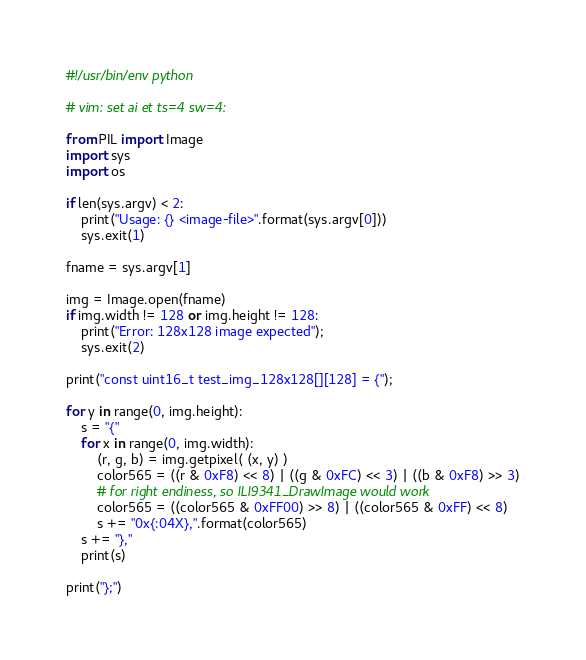Convert code to text. <code><loc_0><loc_0><loc_500><loc_500><_Python_>#!/usr/bin/env python

# vim: set ai et ts=4 sw=4:

from PIL import Image
import sys
import os

if len(sys.argv) < 2:
    print("Usage: {} <image-file>".format(sys.argv[0]))
    sys.exit(1)

fname = sys.argv[1]

img = Image.open(fname)
if img.width != 128 or img.height != 128:
    print("Error: 128x128 image expected");
    sys.exit(2)

print("const uint16_t test_img_128x128[][128] = {");

for y in range(0, img.height):
    s = "{"
    for x in range(0, img.width):
        (r, g, b) = img.getpixel( (x, y) )
        color565 = ((r & 0xF8) << 8) | ((g & 0xFC) << 3) | ((b & 0xF8) >> 3)
        # for right endiness, so ILI9341_DrawImage would work
        color565 = ((color565 & 0xFF00) >> 8) | ((color565 & 0xFF) << 8)
        s += "0x{:04X},".format(color565)
    s += "},"
    print(s)

print("};")
</code> 